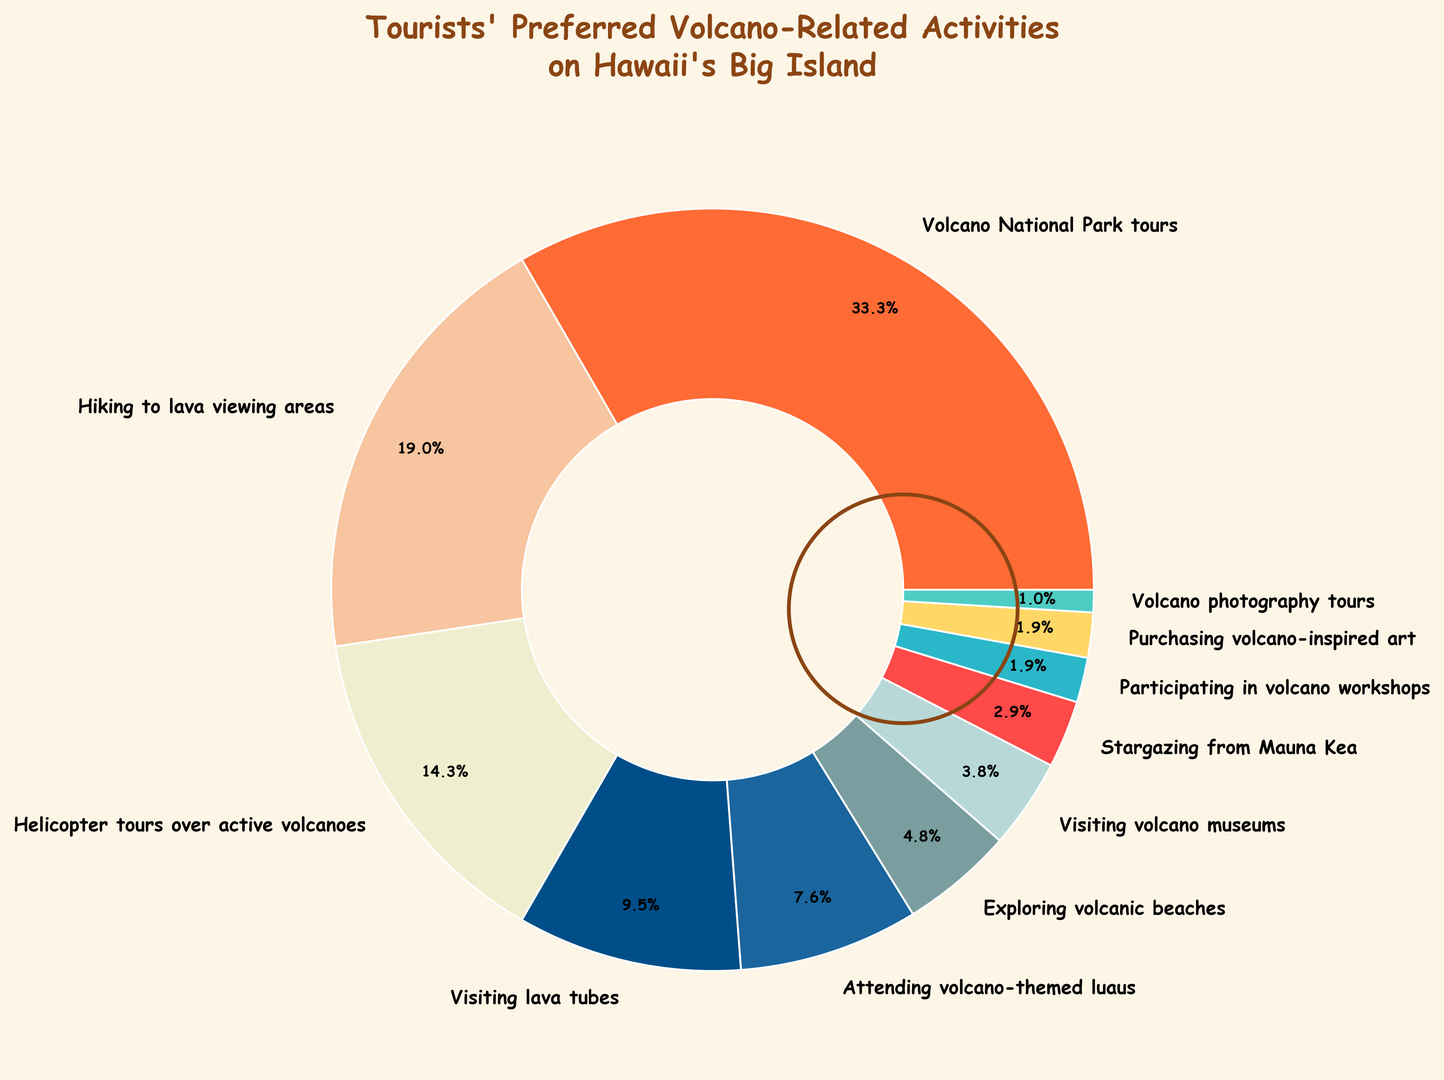What activity is preferred by the most tourists? The largest segment in the pie chart, representing 35% of the total, is labeled "Volcano National Park tours." This indicates that this activity is the most popular among tourists.
Answer: Volcano National Park tours What is the combined percentage of tourists who prefer Helicopter tours over active volcanoes and Hiking to lava viewing areas? The pie chart shows that 15% of tourists prefer Helicopter tours over active volcanoes and 20% prefer Hiking to lava viewing areas. Summing these percentages gives 15% + 20% = 35%.
Answer: 35% Which activity is less popular: Visiting lava tubes or Attending volcano-themed luaus? By comparing the two segments in the pie chart, Visiting lava tubes is shown as 10%, whereas Attending volcano-themed luaus is shown as 8%. Thus, Attending volcano-themed luaus is less popular.
Answer: Attending volcano-themed luaus How much more popular is Exploring volcanic beaches compared to Visiting volcano museums? Exploring volcanic beaches has a percentage of 5%, while Visiting volcano museums has 4%. The difference in their popularity is 5% - 4% = 1%.
Answer: 1% What activities have the same percentage of tourists preferring them? The pie chart shows that both Participating in volcano workshops and Purchasing volcano-inspired art have a preference percentage of 2%.
Answer: Participating in volcano workshops and Purchasing volcano-inspired art What is the combined percentage of tourists who prefer all activities listed with a percentage lower than 5%? According to the pie chart, the activities with percentages lower than 5% are Visiting volcano museums (4%), Stargazing from Mauna Kea (3%), Participating in volcano workshops (2%), Purchasing volcano-inspired art (2%), and Volcano photography tours (1%). Summing these gives 4% + 3% + 2% + 2% + 1% = 12%.
Answer: 12% What percentage of tourists prefer activities related to seeing actual lava (in any form)? Activities related to seeing lava include Hiking to lava viewing areas (20%), Helicopter tours over active volcanoes (15%), and Visiting lava tubes (10%). Adding these percentages gives 20% + 15% + 10% = 45%.
Answer: 45% Which activity is the least popular among tourists? The smallest segment in the pie chart, representing 1% of the total, is labeled "Volcano photography tours." This indicates that this activity is the least popular among tourists.
Answer: Volcano photography tours 